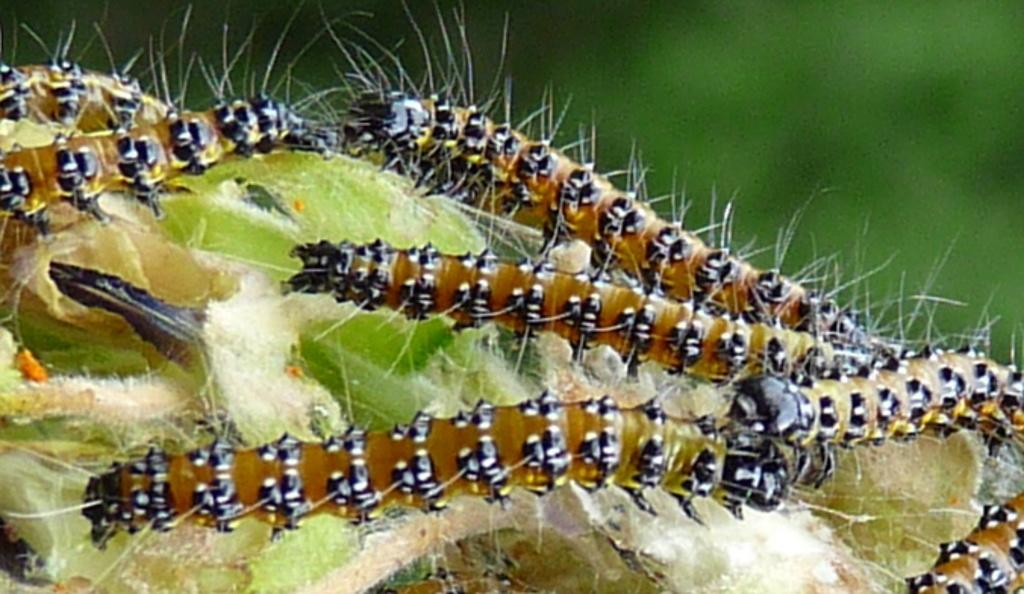What type of animals are present in the image? There are caterpillars in the image. Can you describe the background of the image? The background of the image is blurry. What type of scale can be seen on the caterpillars in the image? There is no scale present on the caterpillars in the image. Can you tell me how many snails are crawling on the caterpillars in the image? There are no snails present in the image; it only features caterpillars. 